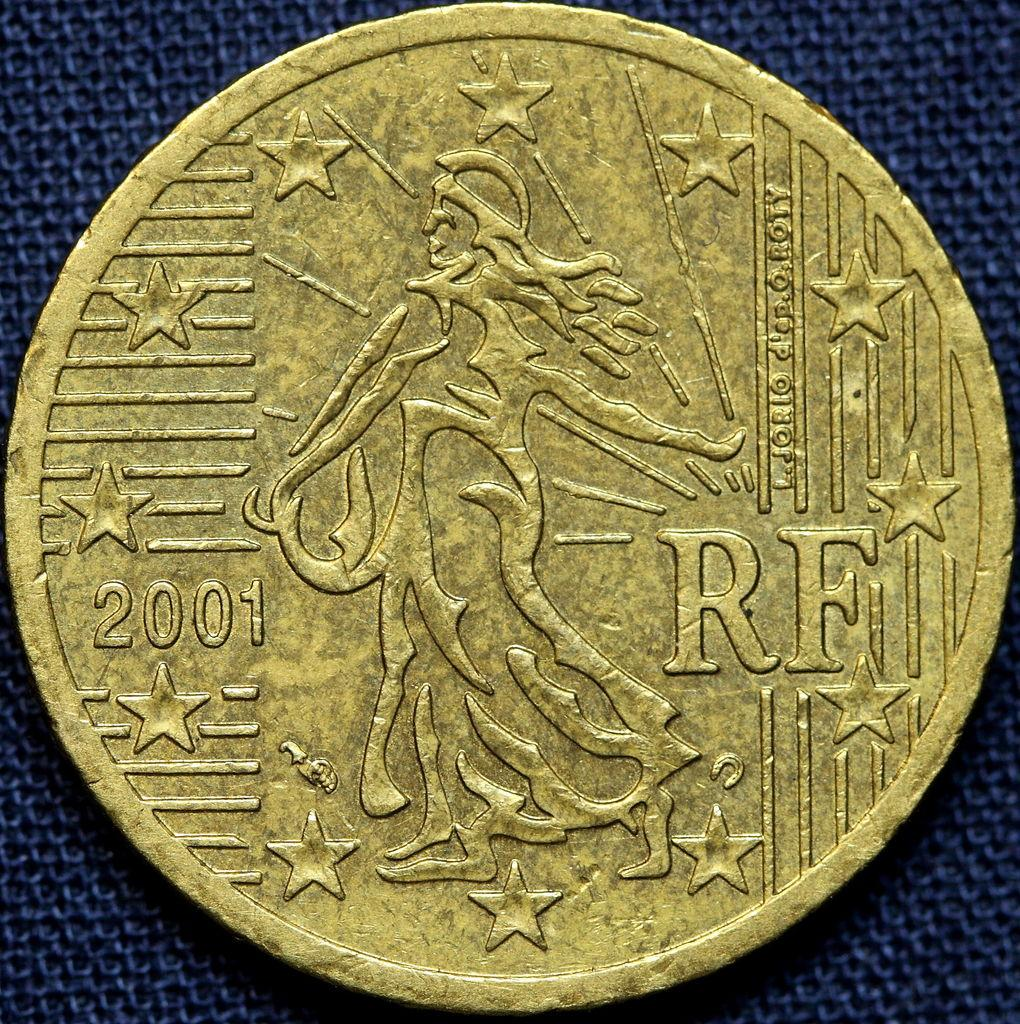<image>
Summarize the visual content of the image. A gold coloured coin with stars and the year 2001 on it. 